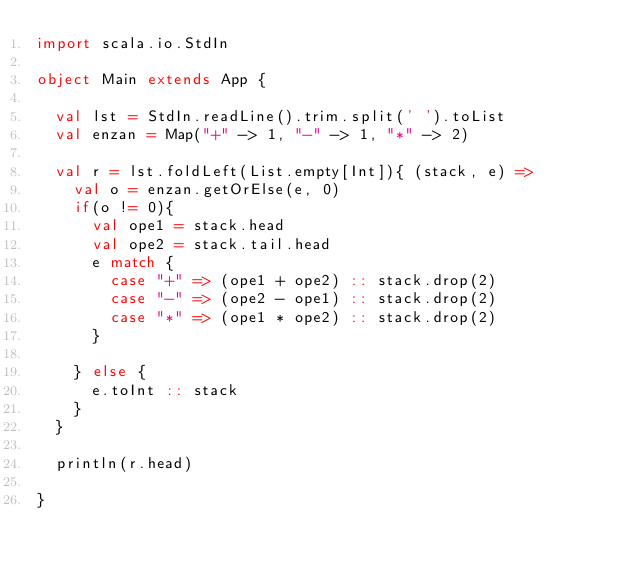Convert code to text. <code><loc_0><loc_0><loc_500><loc_500><_Scala_>import scala.io.StdIn

object Main extends App {

  val lst = StdIn.readLine().trim.split(' ').toList
  val enzan = Map("+" -> 1, "-" -> 1, "*" -> 2)
  
  val r = lst.foldLeft(List.empty[Int]){ (stack, e) =>
    val o = enzan.getOrElse(e, 0)
    if(o != 0){
      val ope1 = stack.head
      val ope2 = stack.tail.head
      e match {
        case "+" => (ope1 + ope2) :: stack.drop(2)
        case "-" => (ope2 - ope1) :: stack.drop(2)
        case "*" => (ope1 * ope2) :: stack.drop(2)
      }
      
    } else {
      e.toInt :: stack
    }
  }
  
  println(r.head)

}

</code> 